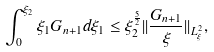Convert formula to latex. <formula><loc_0><loc_0><loc_500><loc_500>\int _ { 0 } ^ { \xi _ { 2 } } \xi _ { 1 } G _ { n + 1 } d \xi _ { 1 } \leq \xi _ { 2 } ^ { \frac { 5 } { 2 } } | | \frac { G _ { n + 1 } } { \xi } | | _ { L ^ { 2 } _ { \xi } } ,</formula> 